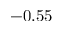<formula> <loc_0><loc_0><loc_500><loc_500>- 0 . 5 5</formula> 